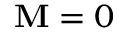Convert formula to latex. <formula><loc_0><loc_0><loc_500><loc_500>M = 0</formula> 